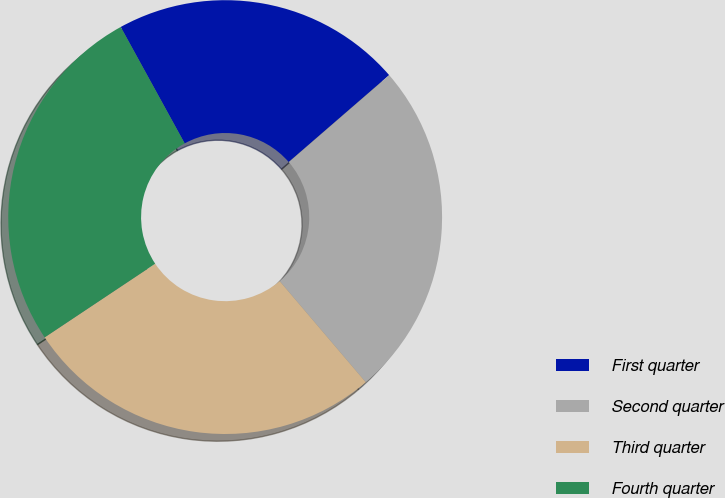<chart> <loc_0><loc_0><loc_500><loc_500><pie_chart><fcel>First quarter<fcel>Second quarter<fcel>Third quarter<fcel>Fourth quarter<nl><fcel>21.64%<fcel>25.13%<fcel>26.87%<fcel>26.36%<nl></chart> 